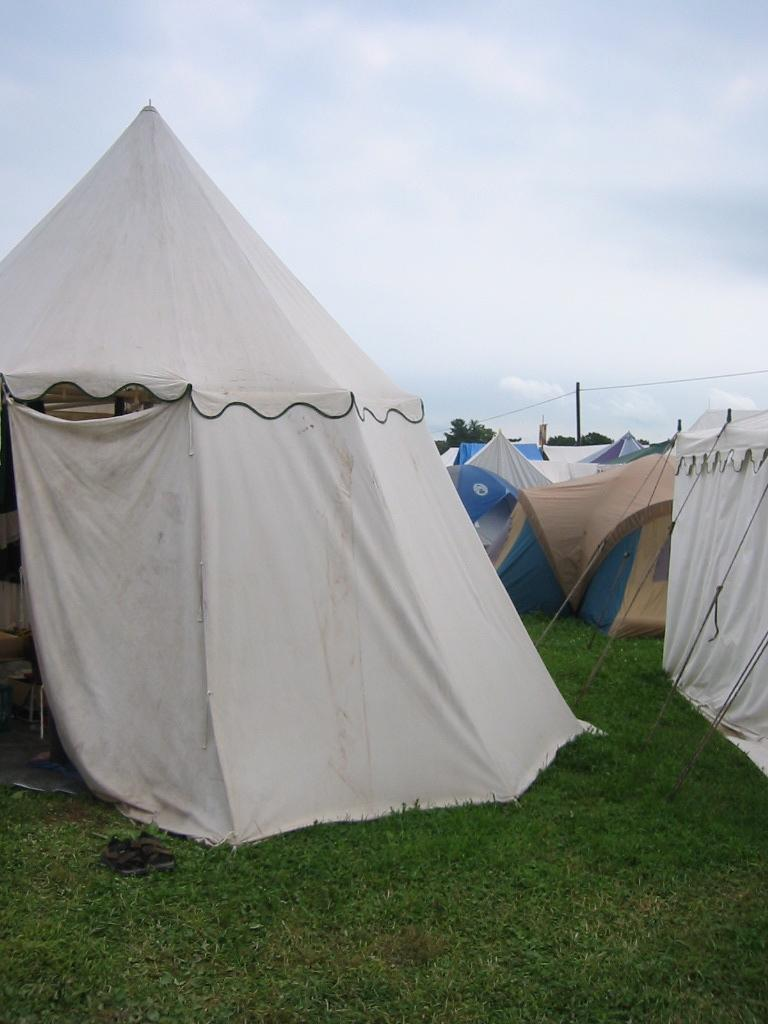What type of vegetation is present in the image? There is grass in the image. What type of temporary shelter can be seen in the image? There are tents in the image. What part of the natural environment is visible in the image? The sky is visible in the background of the image. What government policies are being discussed in the image? There is no indication of any government policies or discussions in the image. 